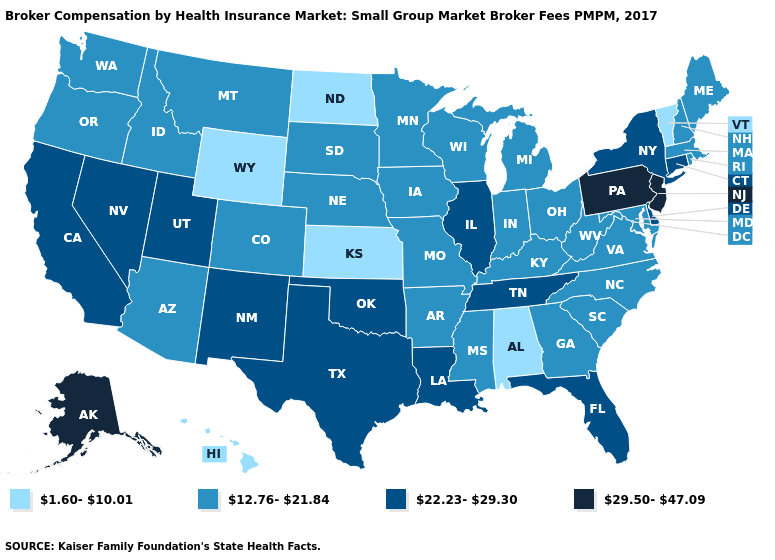Which states hav the highest value in the South?
Concise answer only. Delaware, Florida, Louisiana, Oklahoma, Tennessee, Texas. Name the states that have a value in the range 22.23-29.30?
Short answer required. California, Connecticut, Delaware, Florida, Illinois, Louisiana, Nevada, New Mexico, New York, Oklahoma, Tennessee, Texas, Utah. Does Connecticut have the lowest value in the Northeast?
Be succinct. No. Does Illinois have the highest value in the MidWest?
Give a very brief answer. Yes. Is the legend a continuous bar?
Answer briefly. No. What is the value of Virginia?
Quick response, please. 12.76-21.84. Does Tennessee have a lower value than Minnesota?
Answer briefly. No. Among the states that border Kansas , which have the highest value?
Give a very brief answer. Oklahoma. Name the states that have a value in the range 12.76-21.84?
Be succinct. Arizona, Arkansas, Colorado, Georgia, Idaho, Indiana, Iowa, Kentucky, Maine, Maryland, Massachusetts, Michigan, Minnesota, Mississippi, Missouri, Montana, Nebraska, New Hampshire, North Carolina, Ohio, Oregon, Rhode Island, South Carolina, South Dakota, Virginia, Washington, West Virginia, Wisconsin. What is the highest value in the MidWest ?
Be succinct. 22.23-29.30. Does Ohio have the lowest value in the USA?
Short answer required. No. Which states have the highest value in the USA?
Answer briefly. Alaska, New Jersey, Pennsylvania. What is the value of Maryland?
Short answer required. 12.76-21.84. Among the states that border Indiana , which have the highest value?
Write a very short answer. Illinois. What is the lowest value in the USA?
Keep it brief. 1.60-10.01. 